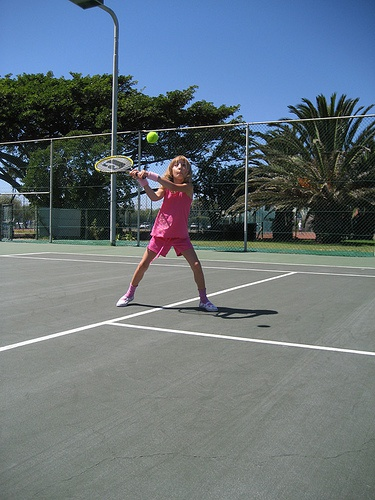Describe the objects in this image and their specific colors. I can see people in gray, maroon, and purple tones, tennis racket in gray, darkgray, lightgray, and black tones, and sports ball in gray, green, yellow, and khaki tones in this image. 